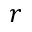Convert formula to latex. <formula><loc_0><loc_0><loc_500><loc_500>r</formula> 